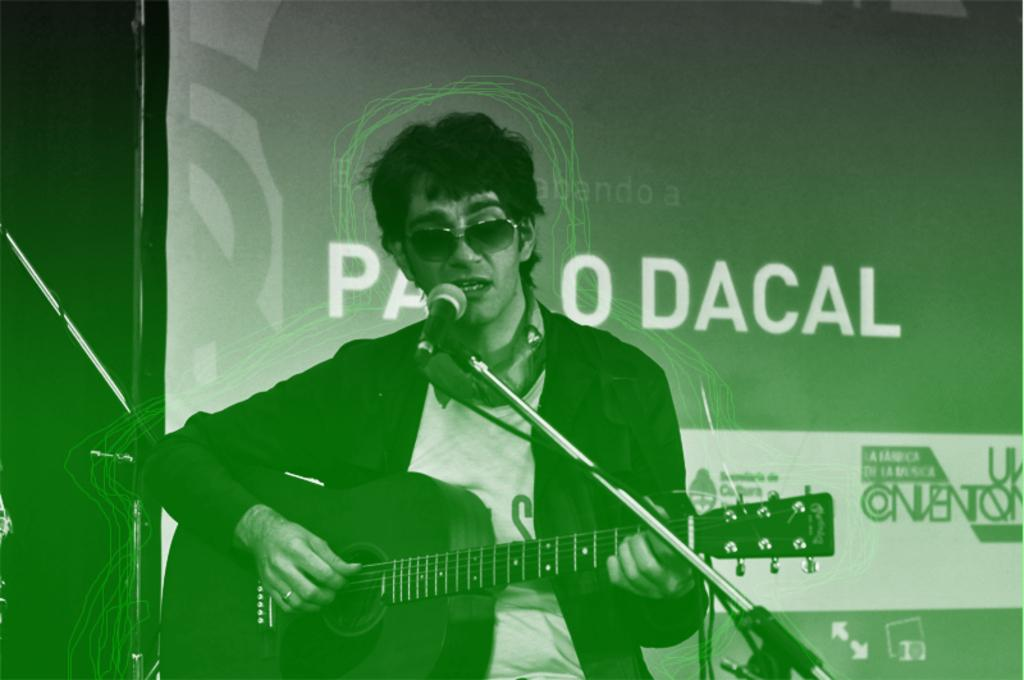What is the person in the image doing? The person is playing a musical instrument in the image. What can be seen near the person in the image? There is a mic and a stand in the image. What is present at the back side of the image? There is a banner at the back there. Can you describe the person's appearance in the image? The person is wearing glasses. What type of rifle can be seen in the person's hand in the image? There is no rifle present in the image; the person is playing a musical instrument. How does the person use the comb while playing the instrument in the image? There is no comb present in the image; the person is wearing glasses. 